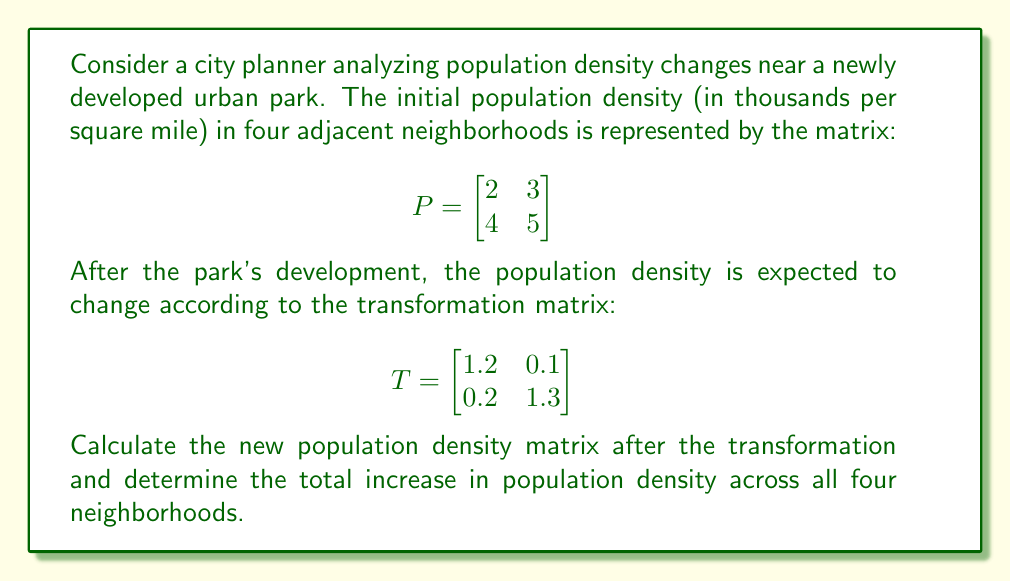Solve this math problem. To solve this problem, we need to follow these steps:

1. Multiply the initial population density matrix P by the transformation matrix T:
   $$P_{new} = T \cdot P$$

2. Perform the matrix multiplication:
   $$P_{new} = \begin{bmatrix}
   1.2 & 0.1 \\
   0.2 & 1.3
   \end{bmatrix} \cdot \begin{bmatrix}
   2 & 3 \\
   4 & 5
   \end{bmatrix}$$

3. Calculate each element of the resulting matrix:
   $$(1.2 \cdot 2 + 0.1 \cdot 4) = 2.8$$
   $$(1.2 \cdot 3 + 0.1 \cdot 5) = 4.1$$
   $$(0.2 \cdot 2 + 1.3 \cdot 4) = 5.6$$
   $$(0.2 \cdot 3 + 1.3 \cdot 5) = 7.1$$

4. Write the new population density matrix:
   $$P_{new} = \begin{bmatrix}
   2.8 & 4.1 \\
   5.6 & 7.1
   \end{bmatrix}$$

5. Calculate the total increase in population density:
   a. Sum all elements in the initial matrix P:
      $2 + 3 + 4 + 5 = 14$
   b. Sum all elements in the new matrix P_new:
      $2.8 + 4.1 + 5.6 + 7.1 = 19.6$
   c. Subtract the initial sum from the new sum:
      $19.6 - 14 = 5.6$

Therefore, the total increase in population density across all four neighborhoods is 5.6 thousand per square mile.
Answer: 5.6 thousand per square mile 